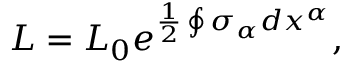Convert formula to latex. <formula><loc_0><loc_0><loc_500><loc_500>L = L _ { 0 } e ^ { \frac { 1 } { 2 } \oint \sigma _ { \alpha } d x ^ { \alpha } } ,</formula> 